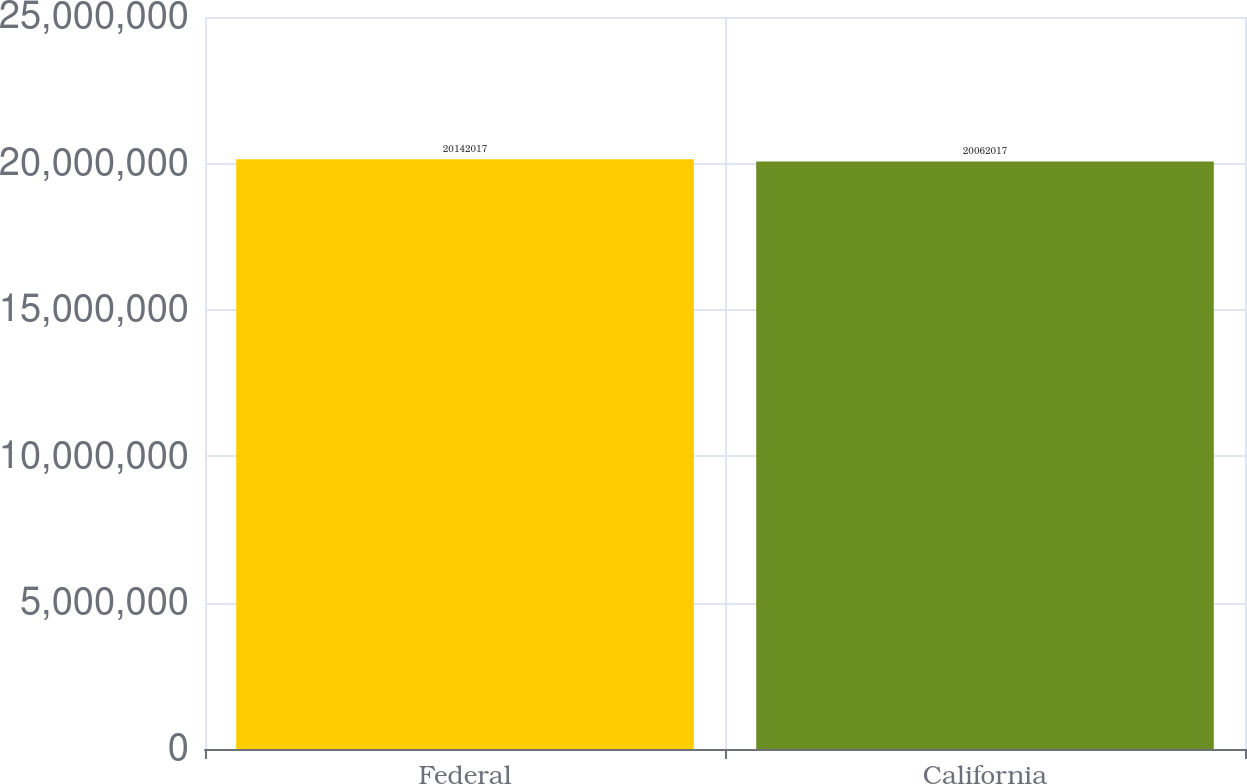Convert chart to OTSL. <chart><loc_0><loc_0><loc_500><loc_500><bar_chart><fcel>Federal<fcel>California<nl><fcel>2.0142e+07<fcel>2.0062e+07<nl></chart> 